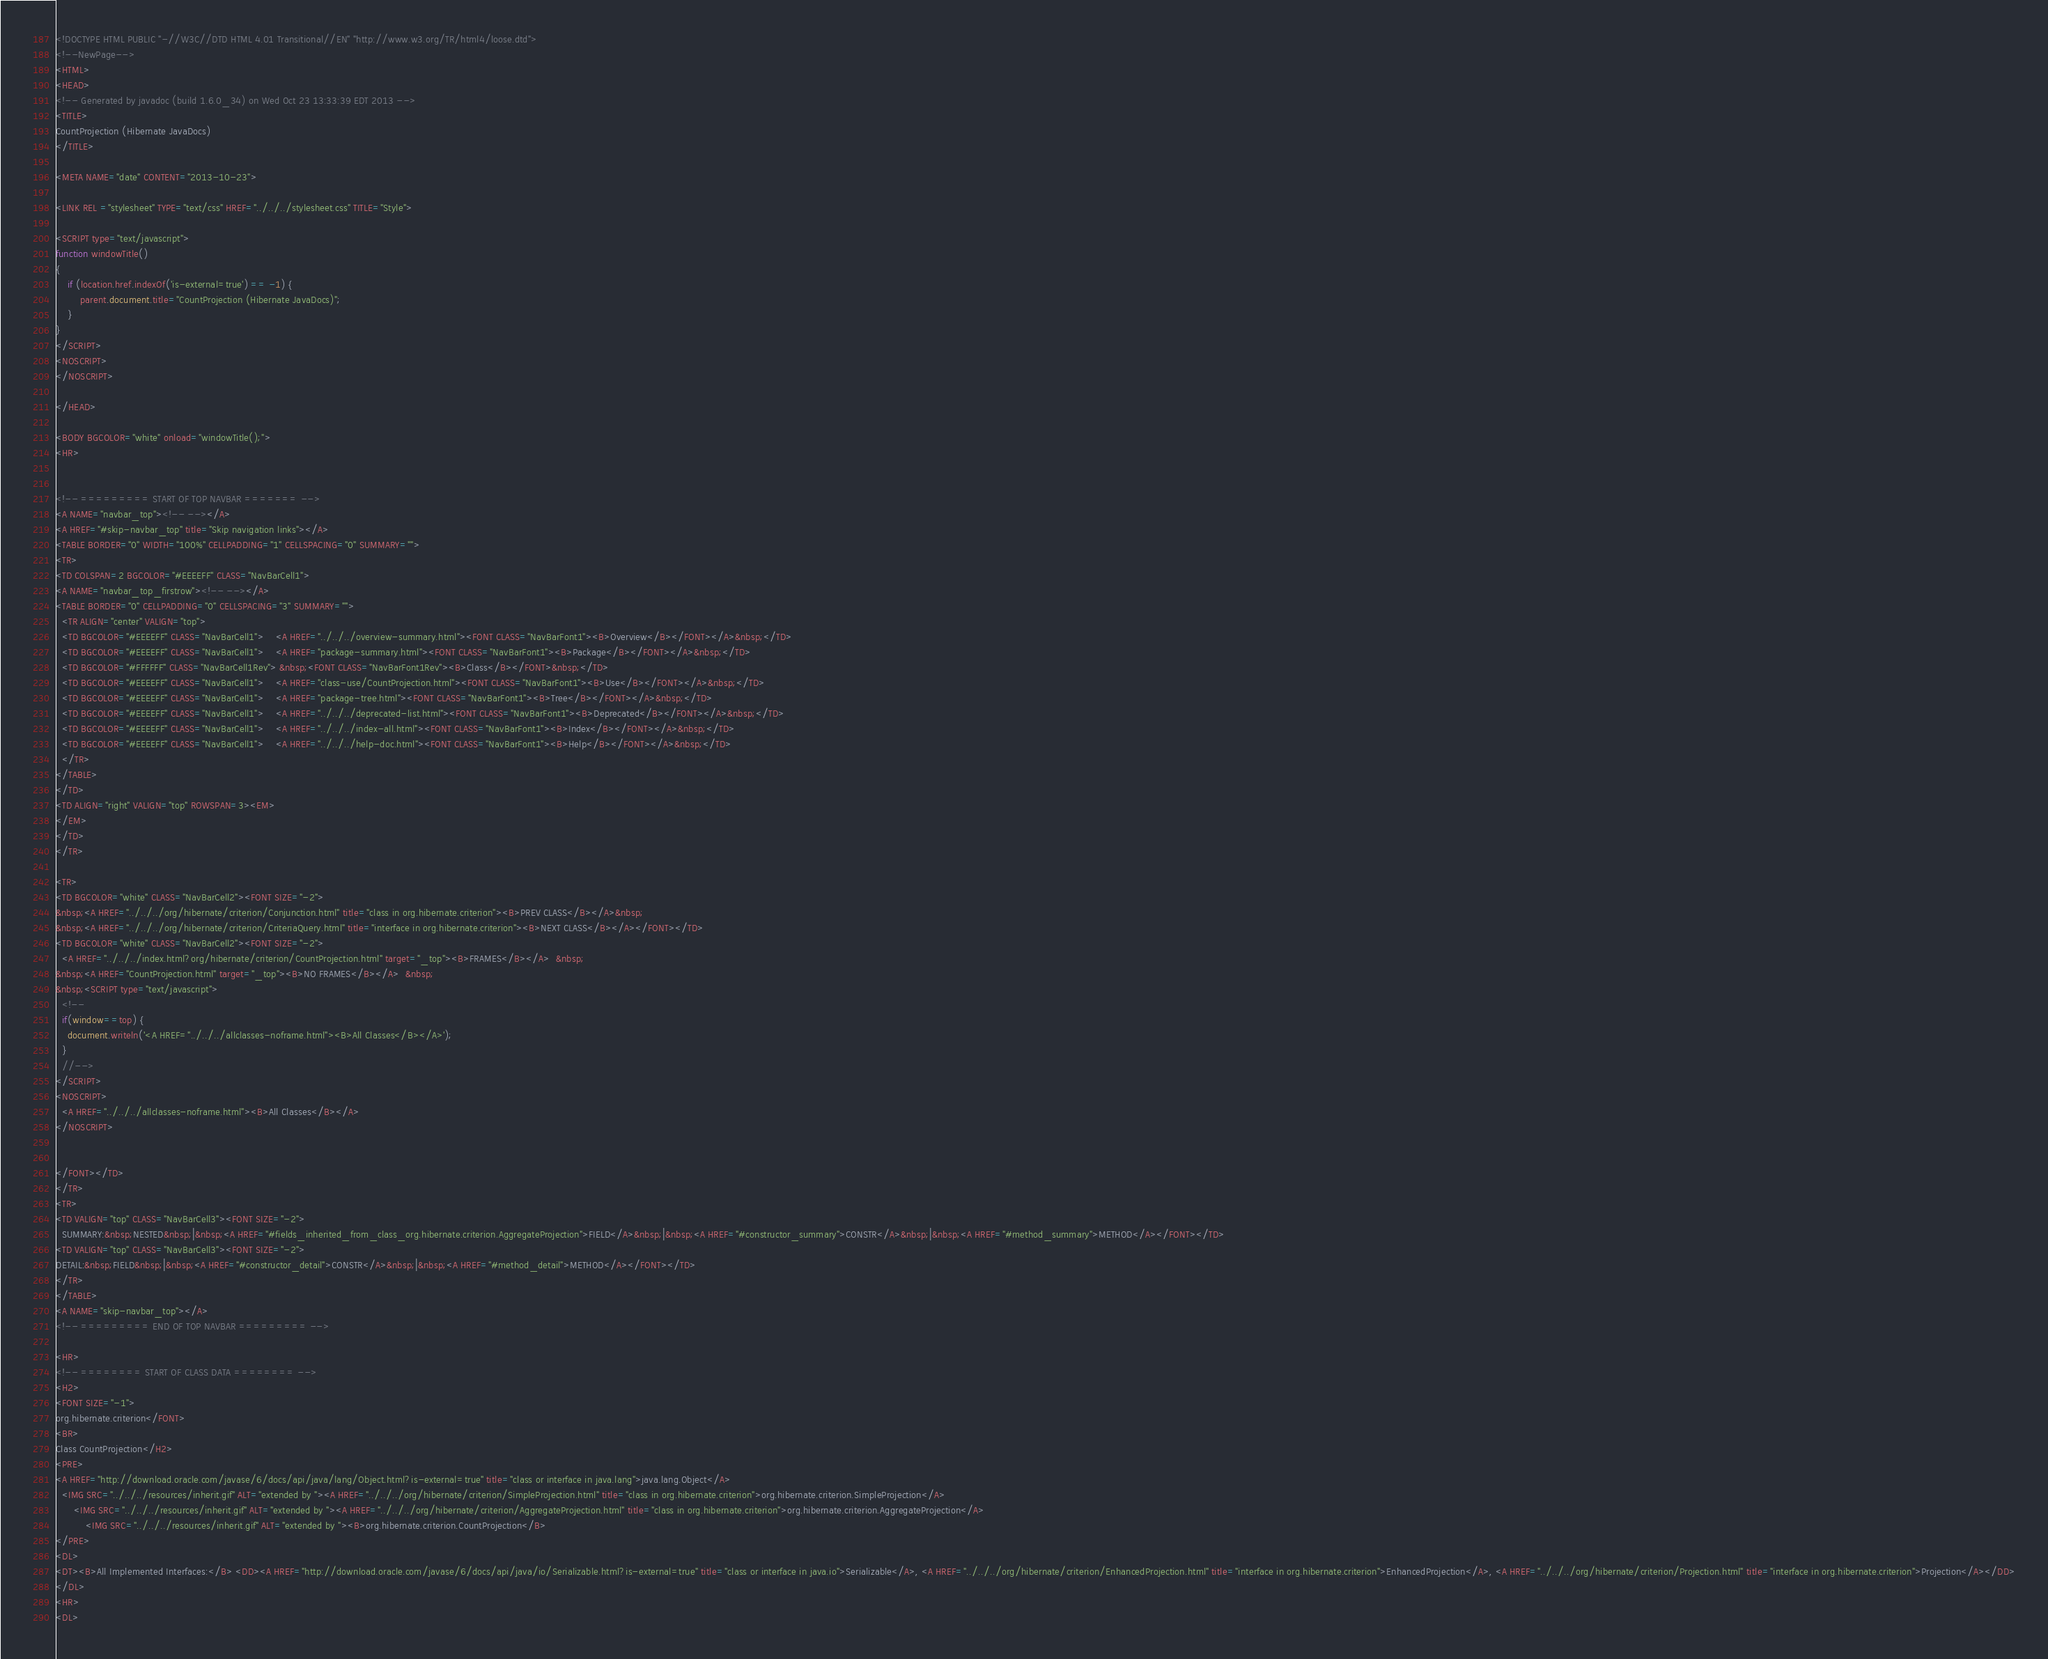<code> <loc_0><loc_0><loc_500><loc_500><_HTML_><!DOCTYPE HTML PUBLIC "-//W3C//DTD HTML 4.01 Transitional//EN" "http://www.w3.org/TR/html4/loose.dtd">
<!--NewPage-->
<HTML>
<HEAD>
<!-- Generated by javadoc (build 1.6.0_34) on Wed Oct 23 13:33:39 EDT 2013 -->
<TITLE>
CountProjection (Hibernate JavaDocs)
</TITLE>

<META NAME="date" CONTENT="2013-10-23">

<LINK REL ="stylesheet" TYPE="text/css" HREF="../../../stylesheet.css" TITLE="Style">

<SCRIPT type="text/javascript">
function windowTitle()
{
    if (location.href.indexOf('is-external=true') == -1) {
        parent.document.title="CountProjection (Hibernate JavaDocs)";
    }
}
</SCRIPT>
<NOSCRIPT>
</NOSCRIPT>

</HEAD>

<BODY BGCOLOR="white" onload="windowTitle();">
<HR>


<!-- ========= START OF TOP NAVBAR ======= -->
<A NAME="navbar_top"><!-- --></A>
<A HREF="#skip-navbar_top" title="Skip navigation links"></A>
<TABLE BORDER="0" WIDTH="100%" CELLPADDING="1" CELLSPACING="0" SUMMARY="">
<TR>
<TD COLSPAN=2 BGCOLOR="#EEEEFF" CLASS="NavBarCell1">
<A NAME="navbar_top_firstrow"><!-- --></A>
<TABLE BORDER="0" CELLPADDING="0" CELLSPACING="3" SUMMARY="">
  <TR ALIGN="center" VALIGN="top">
  <TD BGCOLOR="#EEEEFF" CLASS="NavBarCell1">    <A HREF="../../../overview-summary.html"><FONT CLASS="NavBarFont1"><B>Overview</B></FONT></A>&nbsp;</TD>
  <TD BGCOLOR="#EEEEFF" CLASS="NavBarCell1">    <A HREF="package-summary.html"><FONT CLASS="NavBarFont1"><B>Package</B></FONT></A>&nbsp;</TD>
  <TD BGCOLOR="#FFFFFF" CLASS="NavBarCell1Rev"> &nbsp;<FONT CLASS="NavBarFont1Rev"><B>Class</B></FONT>&nbsp;</TD>
  <TD BGCOLOR="#EEEEFF" CLASS="NavBarCell1">    <A HREF="class-use/CountProjection.html"><FONT CLASS="NavBarFont1"><B>Use</B></FONT></A>&nbsp;</TD>
  <TD BGCOLOR="#EEEEFF" CLASS="NavBarCell1">    <A HREF="package-tree.html"><FONT CLASS="NavBarFont1"><B>Tree</B></FONT></A>&nbsp;</TD>
  <TD BGCOLOR="#EEEEFF" CLASS="NavBarCell1">    <A HREF="../../../deprecated-list.html"><FONT CLASS="NavBarFont1"><B>Deprecated</B></FONT></A>&nbsp;</TD>
  <TD BGCOLOR="#EEEEFF" CLASS="NavBarCell1">    <A HREF="../../../index-all.html"><FONT CLASS="NavBarFont1"><B>Index</B></FONT></A>&nbsp;</TD>
  <TD BGCOLOR="#EEEEFF" CLASS="NavBarCell1">    <A HREF="../../../help-doc.html"><FONT CLASS="NavBarFont1"><B>Help</B></FONT></A>&nbsp;</TD>
  </TR>
</TABLE>
</TD>
<TD ALIGN="right" VALIGN="top" ROWSPAN=3><EM>
</EM>
</TD>
</TR>

<TR>
<TD BGCOLOR="white" CLASS="NavBarCell2"><FONT SIZE="-2">
&nbsp;<A HREF="../../../org/hibernate/criterion/Conjunction.html" title="class in org.hibernate.criterion"><B>PREV CLASS</B></A>&nbsp;
&nbsp;<A HREF="../../../org/hibernate/criterion/CriteriaQuery.html" title="interface in org.hibernate.criterion"><B>NEXT CLASS</B></A></FONT></TD>
<TD BGCOLOR="white" CLASS="NavBarCell2"><FONT SIZE="-2">
  <A HREF="../../../index.html?org/hibernate/criterion/CountProjection.html" target="_top"><B>FRAMES</B></A>  &nbsp;
&nbsp;<A HREF="CountProjection.html" target="_top"><B>NO FRAMES</B></A>  &nbsp;
&nbsp;<SCRIPT type="text/javascript">
  <!--
  if(window==top) {
    document.writeln('<A HREF="../../../allclasses-noframe.html"><B>All Classes</B></A>');
  }
  //-->
</SCRIPT>
<NOSCRIPT>
  <A HREF="../../../allclasses-noframe.html"><B>All Classes</B></A>
</NOSCRIPT>


</FONT></TD>
</TR>
<TR>
<TD VALIGN="top" CLASS="NavBarCell3"><FONT SIZE="-2">
  SUMMARY:&nbsp;NESTED&nbsp;|&nbsp;<A HREF="#fields_inherited_from_class_org.hibernate.criterion.AggregateProjection">FIELD</A>&nbsp;|&nbsp;<A HREF="#constructor_summary">CONSTR</A>&nbsp;|&nbsp;<A HREF="#method_summary">METHOD</A></FONT></TD>
<TD VALIGN="top" CLASS="NavBarCell3"><FONT SIZE="-2">
DETAIL:&nbsp;FIELD&nbsp;|&nbsp;<A HREF="#constructor_detail">CONSTR</A>&nbsp;|&nbsp;<A HREF="#method_detail">METHOD</A></FONT></TD>
</TR>
</TABLE>
<A NAME="skip-navbar_top"></A>
<!-- ========= END OF TOP NAVBAR ========= -->

<HR>
<!-- ======== START OF CLASS DATA ======== -->
<H2>
<FONT SIZE="-1">
org.hibernate.criterion</FONT>
<BR>
Class CountProjection</H2>
<PRE>
<A HREF="http://download.oracle.com/javase/6/docs/api/java/lang/Object.html?is-external=true" title="class or interface in java.lang">java.lang.Object</A>
  <IMG SRC="../../../resources/inherit.gif" ALT="extended by "><A HREF="../../../org/hibernate/criterion/SimpleProjection.html" title="class in org.hibernate.criterion">org.hibernate.criterion.SimpleProjection</A>
      <IMG SRC="../../../resources/inherit.gif" ALT="extended by "><A HREF="../../../org/hibernate/criterion/AggregateProjection.html" title="class in org.hibernate.criterion">org.hibernate.criterion.AggregateProjection</A>
          <IMG SRC="../../../resources/inherit.gif" ALT="extended by "><B>org.hibernate.criterion.CountProjection</B>
</PRE>
<DL>
<DT><B>All Implemented Interfaces:</B> <DD><A HREF="http://download.oracle.com/javase/6/docs/api/java/io/Serializable.html?is-external=true" title="class or interface in java.io">Serializable</A>, <A HREF="../../../org/hibernate/criterion/EnhancedProjection.html" title="interface in org.hibernate.criterion">EnhancedProjection</A>, <A HREF="../../../org/hibernate/criterion/Projection.html" title="interface in org.hibernate.criterion">Projection</A></DD>
</DL>
<HR>
<DL></code> 